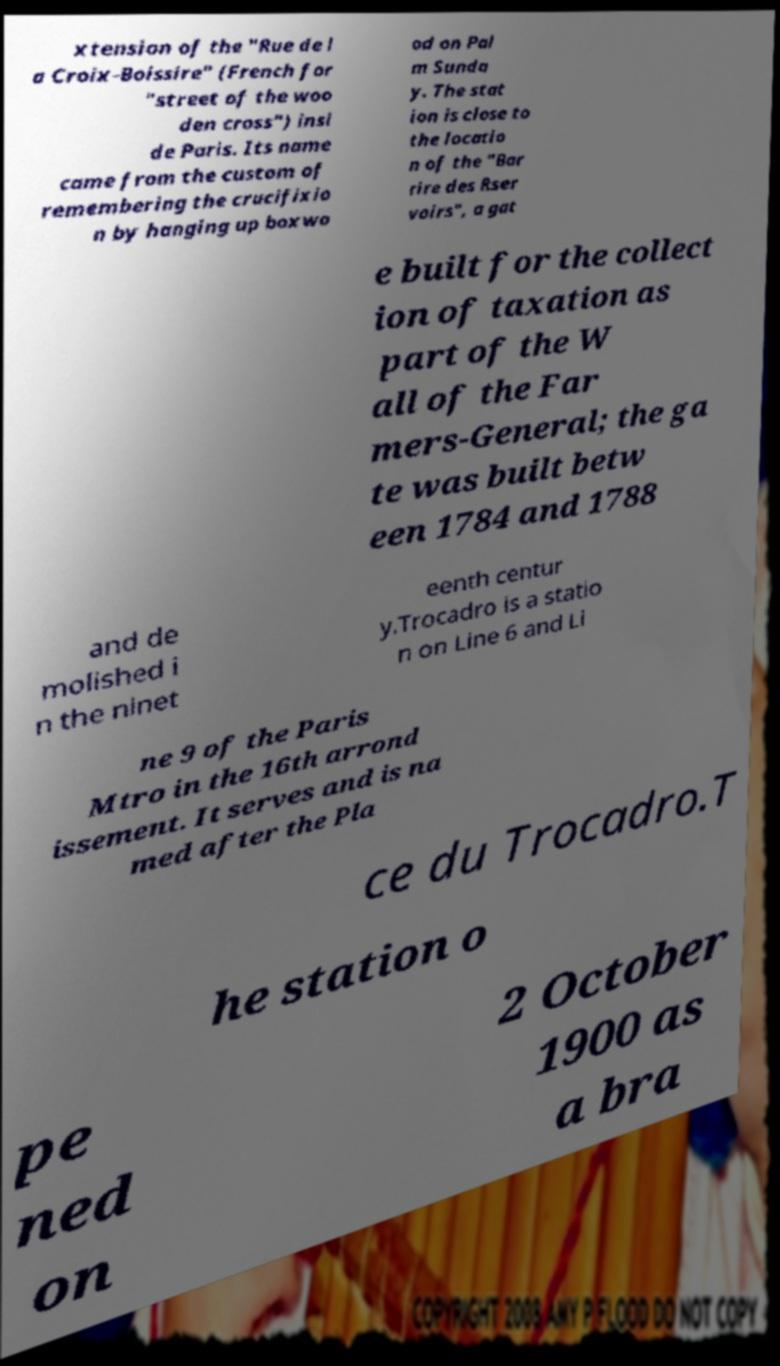Please identify and transcribe the text found in this image. xtension of the "Rue de l a Croix-Boissire" (French for "street of the woo den cross") insi de Paris. Its name came from the custom of remembering the crucifixio n by hanging up boxwo od on Pal m Sunda y. The stat ion is close to the locatio n of the "Bar rire des Rser voirs", a gat e built for the collect ion of taxation as part of the W all of the Far mers-General; the ga te was built betw een 1784 and 1788 and de molished i n the ninet eenth centur y.Trocadro is a statio n on Line 6 and Li ne 9 of the Paris Mtro in the 16th arrond issement. It serves and is na med after the Pla ce du Trocadro.T he station o pe ned on 2 October 1900 as a bra 